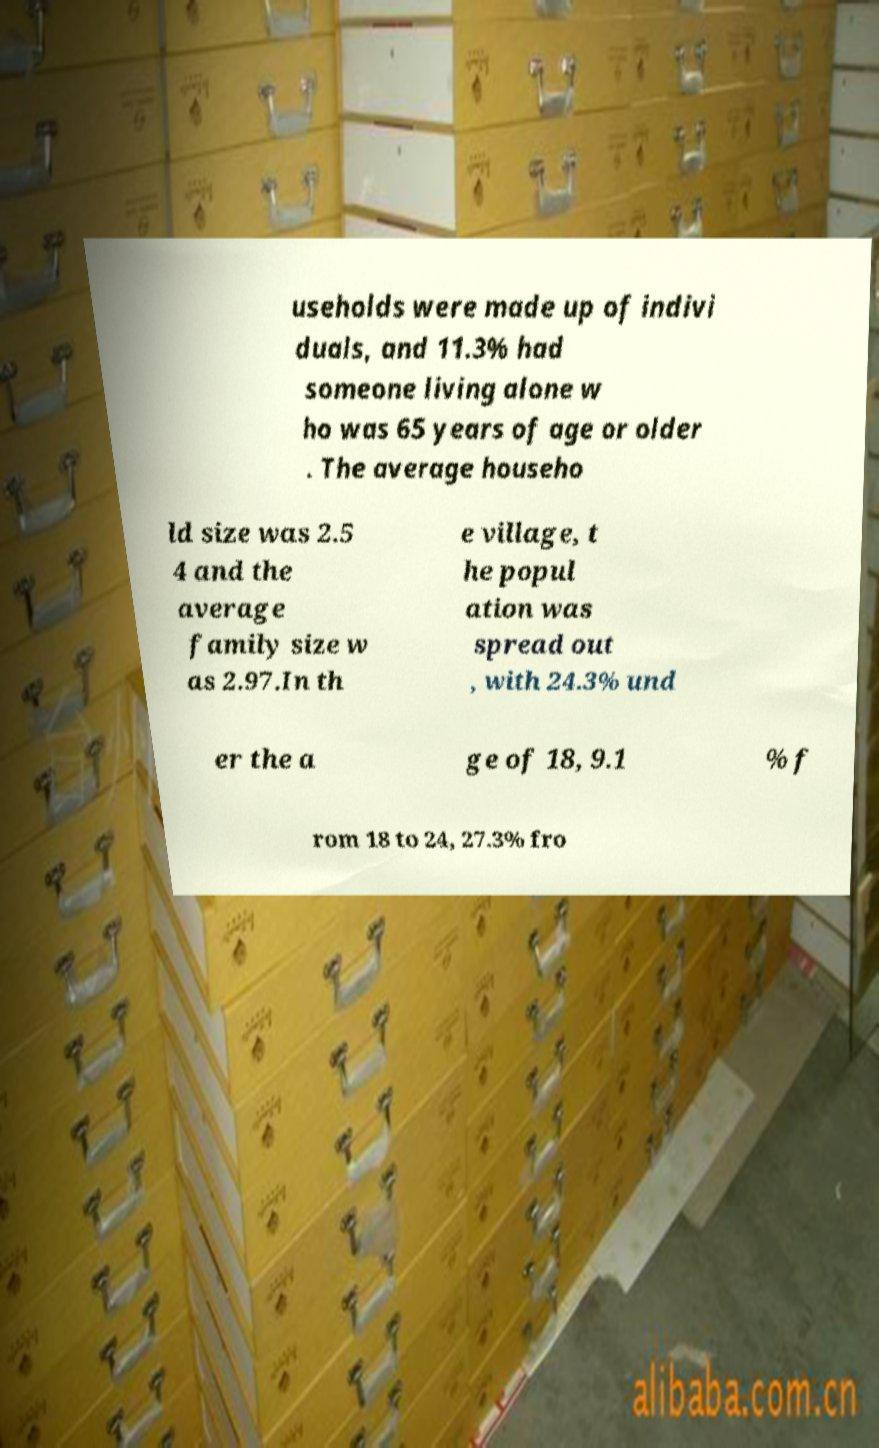Can you read and provide the text displayed in the image?This photo seems to have some interesting text. Can you extract and type it out for me? useholds were made up of indivi duals, and 11.3% had someone living alone w ho was 65 years of age or older . The average househo ld size was 2.5 4 and the average family size w as 2.97.In th e village, t he popul ation was spread out , with 24.3% und er the a ge of 18, 9.1 % f rom 18 to 24, 27.3% fro 